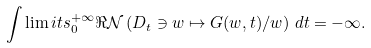<formula> <loc_0><loc_0><loc_500><loc_500>\int \lim i t s _ { 0 } ^ { + \infty } \Re \mathcal { N } \left ( D _ { t } \ni w \mapsto G ( w , t ) / w \right ) \, d t = - \infty .</formula> 